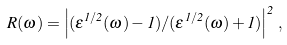<formula> <loc_0><loc_0><loc_500><loc_500>R ( \omega ) = \left | ( \epsilon ^ { 1 / 2 } ( \omega ) - 1 ) / ( \epsilon ^ { 1 / 2 } ( \omega ) + 1 ) \right | ^ { 2 } \, ,</formula> 